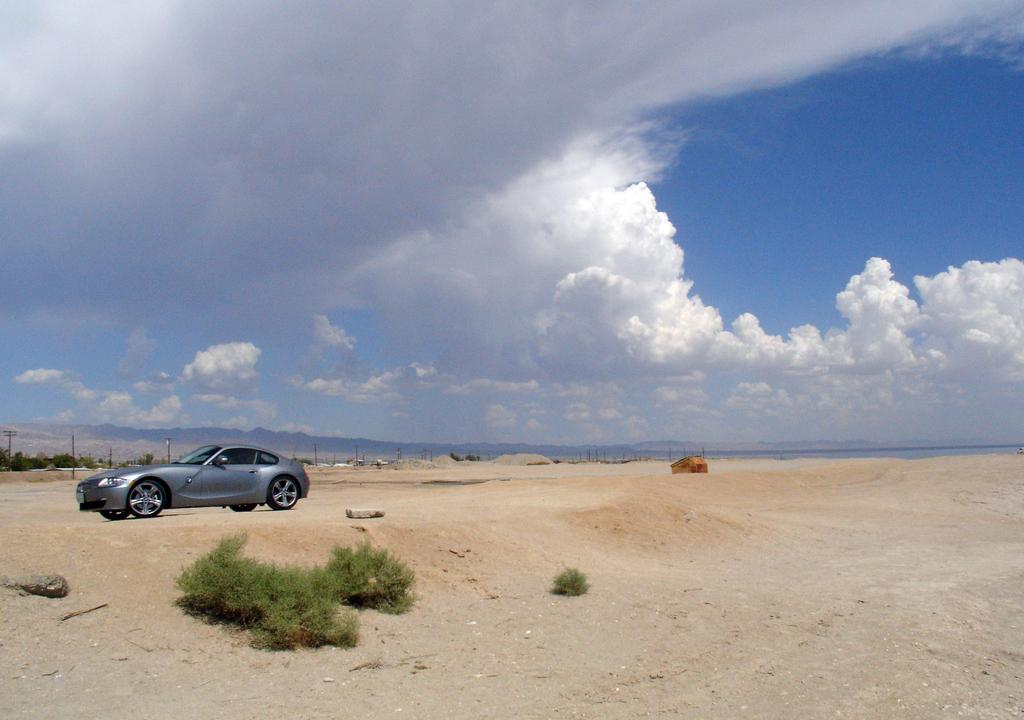What type of living organisms can be seen in the image? Plants can be seen in the image. What is located on the left side of the image? There is a car on the left side of the image. What structure is in the middle of the image? There appears to be a hut in the middle of the image. What is visible at the top of the image? The sky is visible at the top of the image. What color is the paint on the body of the car in the image? There is no mention of the car's color or any paint in the provided facts, so we cannot answer this question. What happens when the hut bursts in the image? There is no indication of a hut bursting in the image, so we cannot answer this question. 